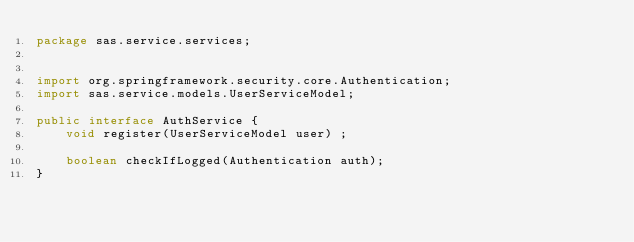Convert code to text. <code><loc_0><loc_0><loc_500><loc_500><_Java_>package sas.service.services;


import org.springframework.security.core.Authentication;
import sas.service.models.UserServiceModel;

public interface AuthService {
    void register(UserServiceModel user) ;

    boolean checkIfLogged(Authentication auth);
}
</code> 